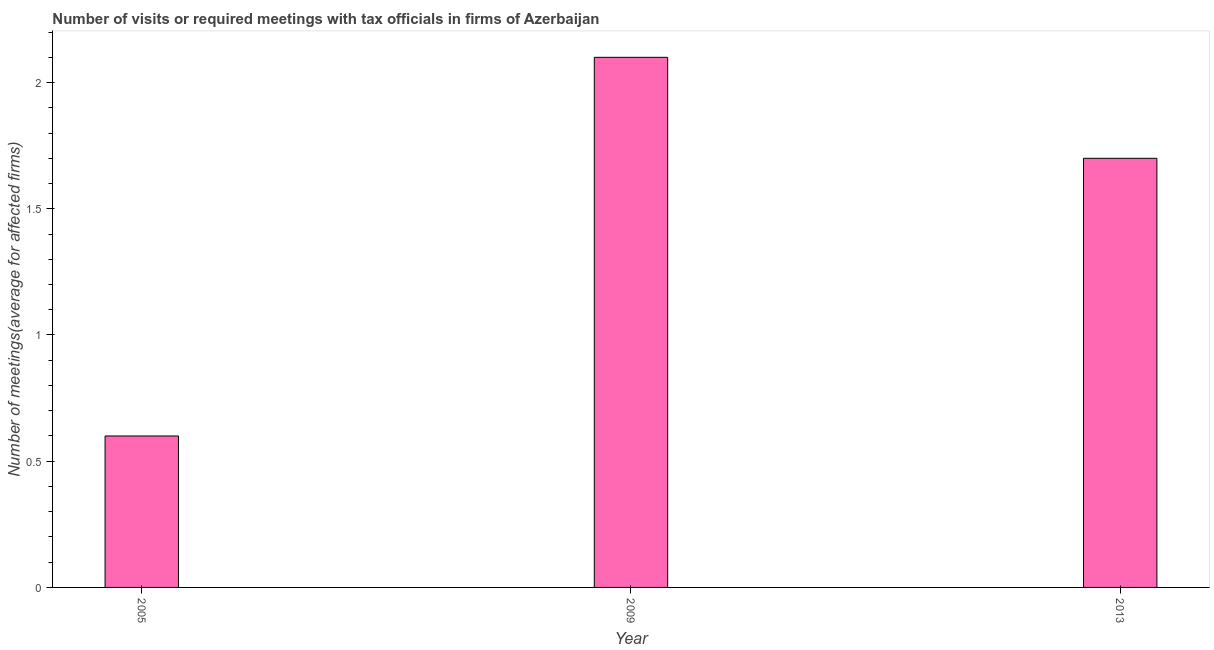Does the graph contain any zero values?
Offer a terse response. No. Does the graph contain grids?
Your response must be concise. No. What is the title of the graph?
Provide a short and direct response. Number of visits or required meetings with tax officials in firms of Azerbaijan. What is the label or title of the Y-axis?
Offer a terse response. Number of meetings(average for affected firms). What is the number of required meetings with tax officials in 2009?
Offer a terse response. 2.1. Across all years, what is the maximum number of required meetings with tax officials?
Offer a terse response. 2.1. In which year was the number of required meetings with tax officials minimum?
Make the answer very short. 2005. What is the sum of the number of required meetings with tax officials?
Offer a very short reply. 4.4. What is the difference between the number of required meetings with tax officials in 2005 and 2013?
Your answer should be compact. -1.1. What is the average number of required meetings with tax officials per year?
Offer a terse response. 1.47. Do a majority of the years between 2013 and 2005 (inclusive) have number of required meetings with tax officials greater than 2 ?
Provide a succinct answer. Yes. What is the ratio of the number of required meetings with tax officials in 2005 to that in 2013?
Your response must be concise. 0.35. Is the number of required meetings with tax officials in 2005 less than that in 2009?
Your answer should be very brief. Yes. Is the difference between the number of required meetings with tax officials in 2005 and 2009 greater than the difference between any two years?
Give a very brief answer. Yes. Is the sum of the number of required meetings with tax officials in 2005 and 2009 greater than the maximum number of required meetings with tax officials across all years?
Offer a terse response. Yes. What is the difference between the highest and the lowest number of required meetings with tax officials?
Keep it short and to the point. 1.5. Are the values on the major ticks of Y-axis written in scientific E-notation?
Give a very brief answer. No. What is the Number of meetings(average for affected firms) of 2005?
Your response must be concise. 0.6. What is the Number of meetings(average for affected firms) in 2009?
Ensure brevity in your answer.  2.1. What is the Number of meetings(average for affected firms) in 2013?
Your answer should be very brief. 1.7. What is the difference between the Number of meetings(average for affected firms) in 2005 and 2013?
Give a very brief answer. -1.1. What is the ratio of the Number of meetings(average for affected firms) in 2005 to that in 2009?
Your response must be concise. 0.29. What is the ratio of the Number of meetings(average for affected firms) in 2005 to that in 2013?
Your response must be concise. 0.35. What is the ratio of the Number of meetings(average for affected firms) in 2009 to that in 2013?
Your answer should be compact. 1.24. 